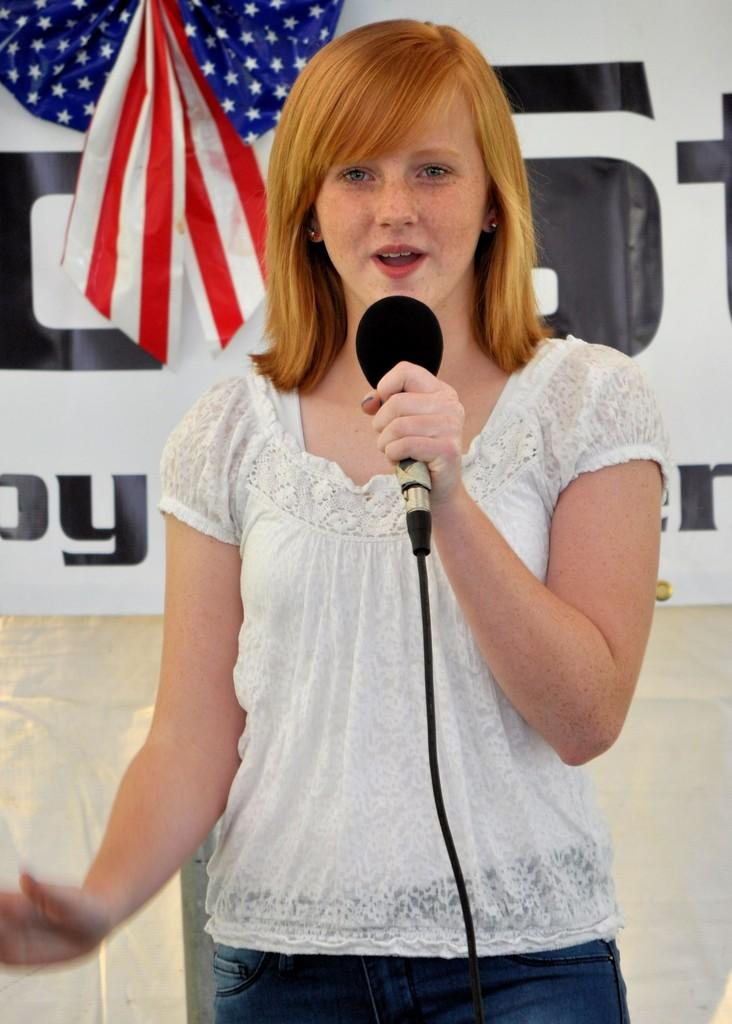Who is the main subject in the image? There is a lady in the image. What is the lady doing in the image? The lady is standing and speaking into a microphone. What can be seen in the background of the image? There is a USA flag and a banner in the image. What type of quince is being used to hold the banner in the image? There is no quince present in the image, and the banner is not being held by any fruit. 